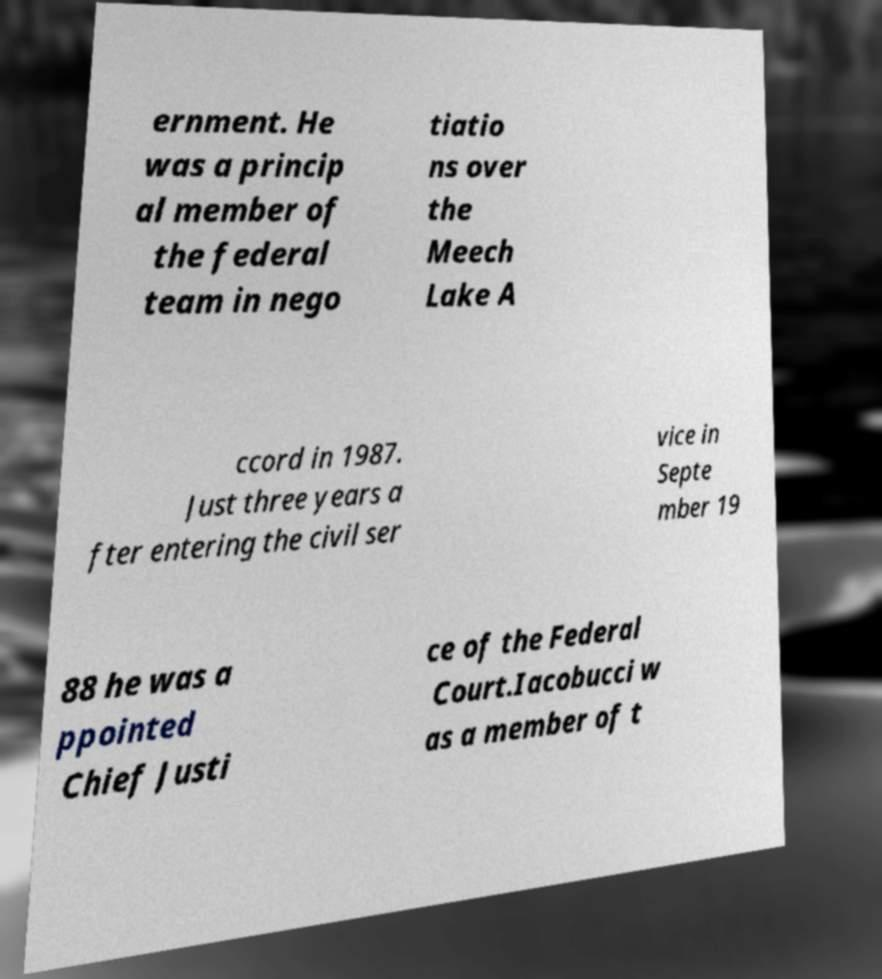What messages or text are displayed in this image? I need them in a readable, typed format. ernment. He was a princip al member of the federal team in nego tiatio ns over the Meech Lake A ccord in 1987. Just three years a fter entering the civil ser vice in Septe mber 19 88 he was a ppointed Chief Justi ce of the Federal Court.Iacobucci w as a member of t 